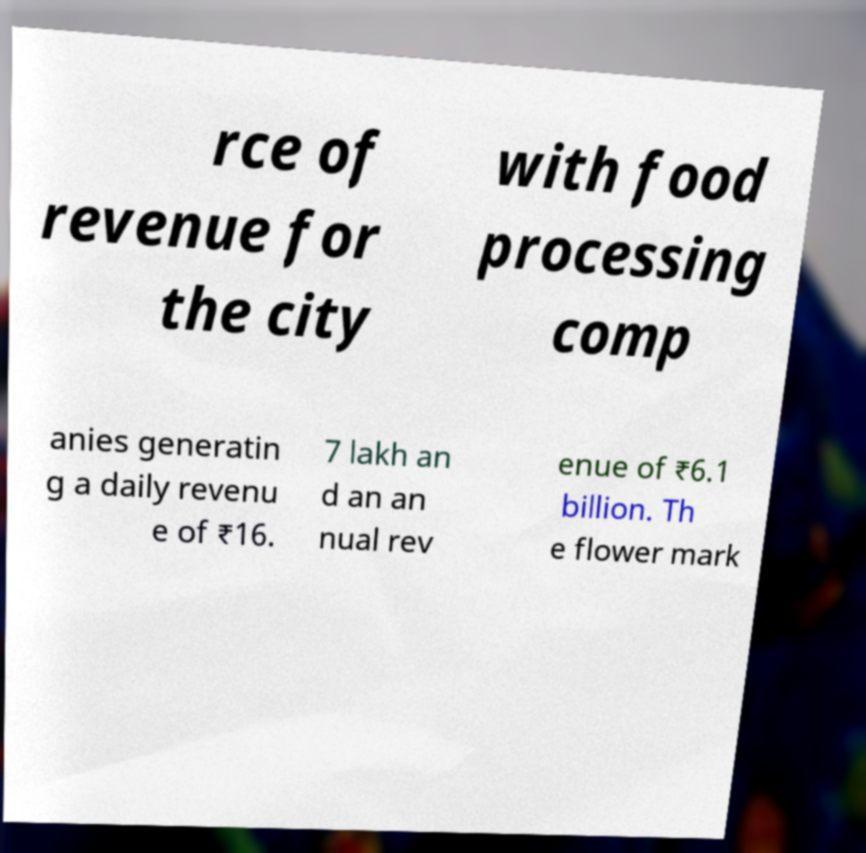Can you accurately transcribe the text from the provided image for me? rce of revenue for the city with food processing comp anies generatin g a daily revenu e of ₹16. 7 lakh an d an an nual rev enue of ₹6.1 billion. Th e flower mark 